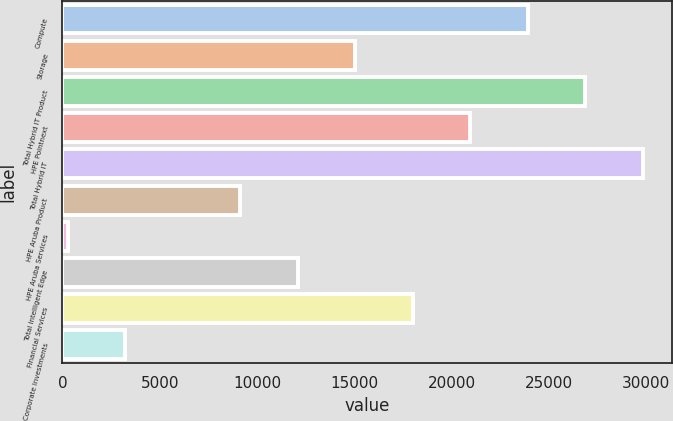<chart> <loc_0><loc_0><loc_500><loc_500><bar_chart><fcel>Compute<fcel>Storage<fcel>Total Hybrid IT Product<fcel>HPE Pointnext<fcel>Total Hybrid IT<fcel>HPE Aruba Product<fcel>HPE Aruba Services<fcel>Total Intelligent Edge<fcel>Financial Services<fcel>Corporate Investments<nl><fcel>23910.2<fcel>15051.5<fcel>26863.1<fcel>20957.3<fcel>29816<fcel>9145.7<fcel>287<fcel>12098.6<fcel>18004.4<fcel>3239.9<nl></chart> 